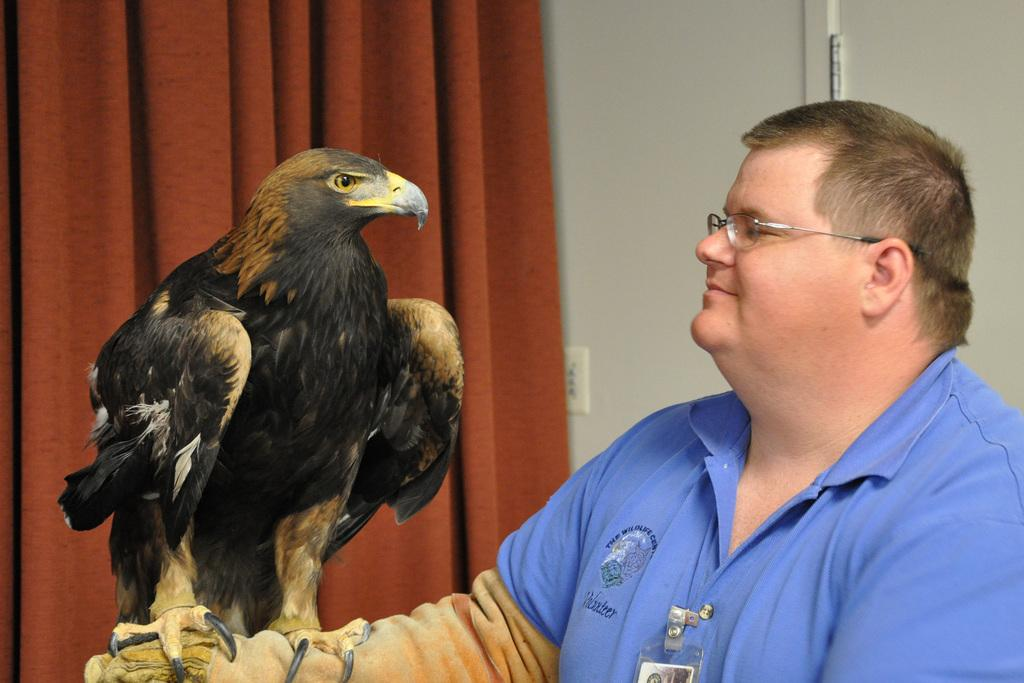Where was the image taken? The image was taken indoors. What can be seen in the background of the image? There is a wall with a door in the background. Is there any window treatment present in the image? Yes, there is a curtain associated with the wall and door. Who is present in the image? There is a man on the right side of the image. What is the man holding in the image? The man is holding an eagle on his hand. How many nuts are visible on the man's sock in the image? There are no nuts or socks visible in the image; the man is holding an eagle on his hand. What type of quarter is depicted on the wall in the image? There is no quarter present in the image; the background features a wall with a door and a curtain. 